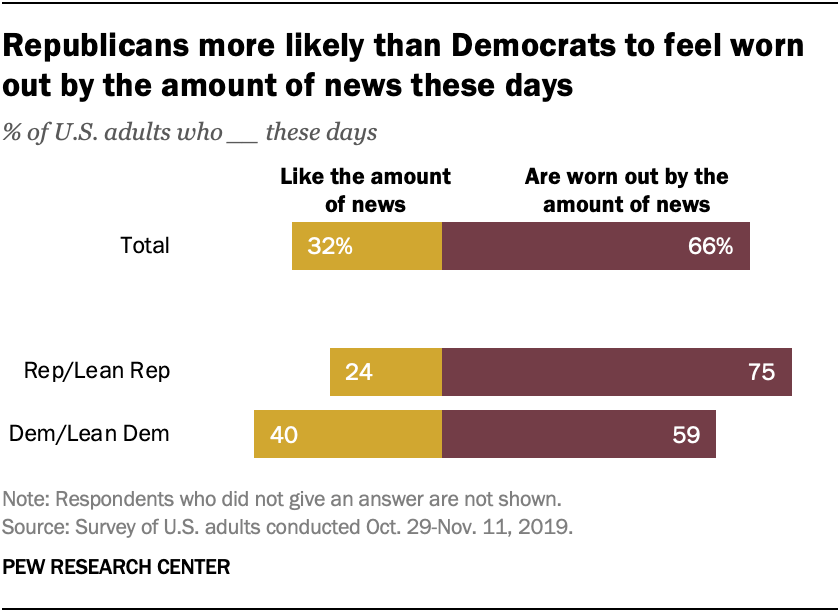Give some essential details in this illustration. The ratio of the two smallest yellow bars is A to B, with A being smaller than B. The ratio is approximately 0.127777778... According to a recent survey, 32% of U.S. adults are satisfied with the amount of news they are currently receiving. 